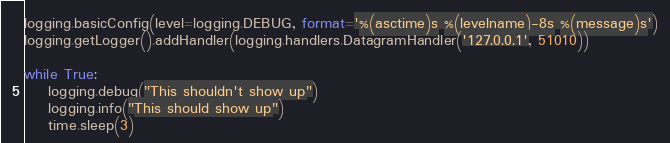<code> <loc_0><loc_0><loc_500><loc_500><_Python_>
logging.basicConfig(level=logging.DEBUG, format='%(asctime)s %(levelname)-8s %(message)s')
logging.getLogger().addHandler(logging.handlers.DatagramHandler('127.0.0.1', 51010))

while True:
    logging.debug("This shouldn't show up")
    logging.info("This should show up")
    time.sleep(3)

</code> 